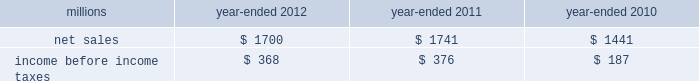74 2012 ppg annual report and form 10-k 25 .
Separation and merger transaction on january , 28 , 2013 , the company completed the previously announced separation of its commodity chemicals business and merger of its wholly-owned subsidiary , eagle spinco inc. , with a subsidiary of georgia gulf corporation in a tax efficient reverse morris trust transaction ( the 201ctransaction 201d ) .
Pursuant to the merger , eagle spinco , the entity holding ppg's former commodity chemicals business , is now a wholly-owned subsidiary of georgia gulf .
The closing of the merger followed the expiration of the related exchange offer and the satisfaction of certain other conditions .
The combined company formed by uniting georgia gulf with ppg's former commodity chemicals business is named axiall corporation ( 201caxiall 201d ) .
Ppg holds no ownership interest in axiall .
Ppg received the necessary ruling from the internal revenue service and as a result this transaction was generally tax free to ppg and its shareholders .
Under the terms of the exchange offer , 35249104 shares of eagle spinco common stock were available for distribution in exchange for shares of ppg common stock accepted in the offer .
Following the merger , each share of eagle spinco common stock automatically converted into the right to receive one share of axiall corporation common stock .
Accordingly , ppg shareholders who tendered their shares of ppg common stock as part of this offer received 3.2562 shares of axiall common stock for each share of ppg common stock accepted for exchange .
Ppg was able to accept the maximum of 10825227 shares of ppg common stock for exchange in the offer , and thereby , reduced its outstanding shares by approximately 7% ( 7 % ) .
Under the terms of the transaction , ppg received $ 900 million of cash and 35.2 million shares of axiall common stock ( market value of $ 1.8 billion on january 25 , 2013 ) which was distributed to ppg shareholders by the exchange offer as described above .
The cash consideration is subject to customary post-closing adjustment , including a working capital adjustment .
In the transaction , ppg transferred environmental remediation liabilities , defined benefit pension plan assets and liabilities and other post-employment benefit liabilities related to the commodity chemicals business to axiall .
Ppg will report a gain on the transaction reflecting the excess of the sum of the cash proceeds received and the cost ( closing stock price on january 25 , 2013 ) of the ppg shares tendered and accepted in the exchange for the 35.2 million shares of axiall common stock over the net book value of the net assets of ppg's former commodity chemicals business .
The transaction will also result in a net partial settlement loss associated with the spin out and termination of defined benefit pension liabilities and the transfer of other post-retirement benefit liabilities under the terms of the transaction .
During 2012 , the company incurred $ 21 million of pretax expense , primarily for professional services , related to the transaction .
Additional transaction-related expenses will be incurred in 2013 .
Ppg will report the results of its commodity chemicals business for january 2013 and a net gain on the transaction as results from discontinued operations when it reports its results for the quarter ending march 31 , 2013 .
In the ppg results for prior periods , presented for comparative purposes beginning with the first quarter 2013 , the results of its former commodity chemicals business will be reclassified from continuing operations and presented as the results from discontinued operations .
The net sales and income before income taxes of the commodity chemicals business that will be reclassified and reported as discontinued operations are presented in the table below for the years ended december 31 , 2012 , 2011 and 2010: .
Income before income taxes for the year ended december 31 , 2012 , 2011 and 2010 is $ 4 million lower , $ 6 million higher and $ 2 million lower , respectively , than segment earnings for the ppg commodity chemicals segment reported for these periods .
These differences are due to the inclusion of certain gains , losses and expenses associated with the chlor-alkali and derivatives business that were not reported in the ppg commodity chemicals segment earnings in accordance with the accounting guidance on segment reporting .
Table of contents notes to the consolidated financial statements .
For the eagle spinoff , how much in total did ppg shareholders receive in us$ b? 
Computations: (((1.8 * 1000) + 900) / 1000)
Answer: 2.7. 